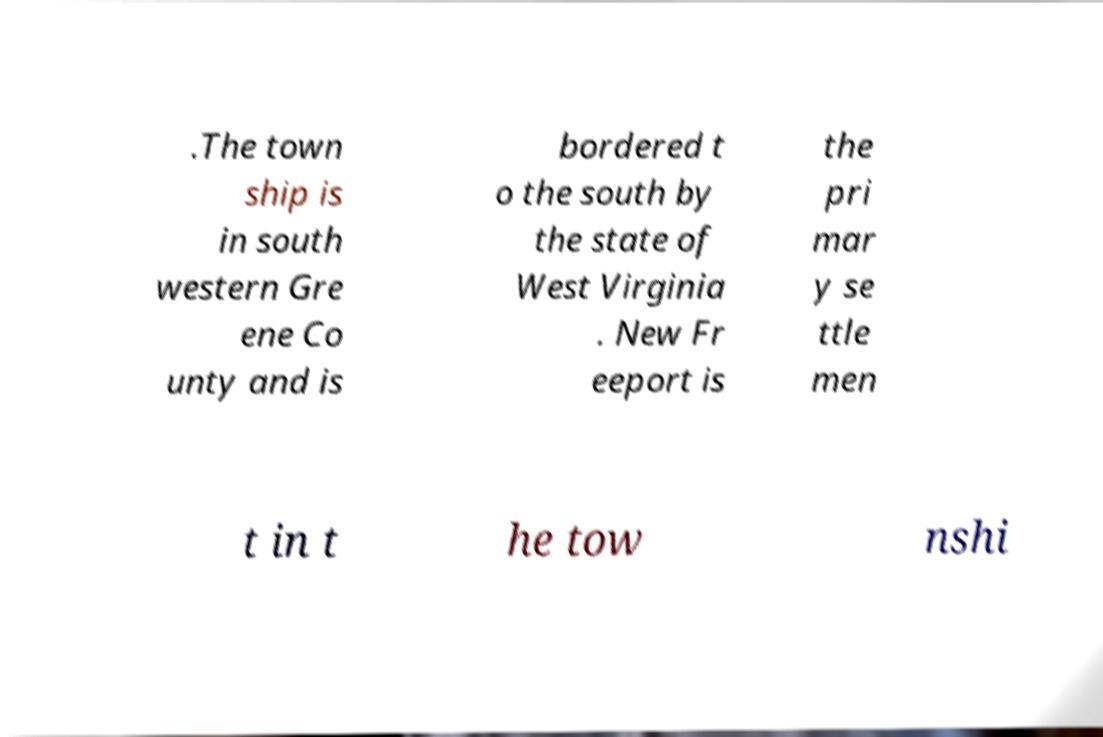Can you read and provide the text displayed in the image?This photo seems to have some interesting text. Can you extract and type it out for me? .The town ship is in south western Gre ene Co unty and is bordered t o the south by the state of West Virginia . New Fr eeport is the pri mar y se ttle men t in t he tow nshi 